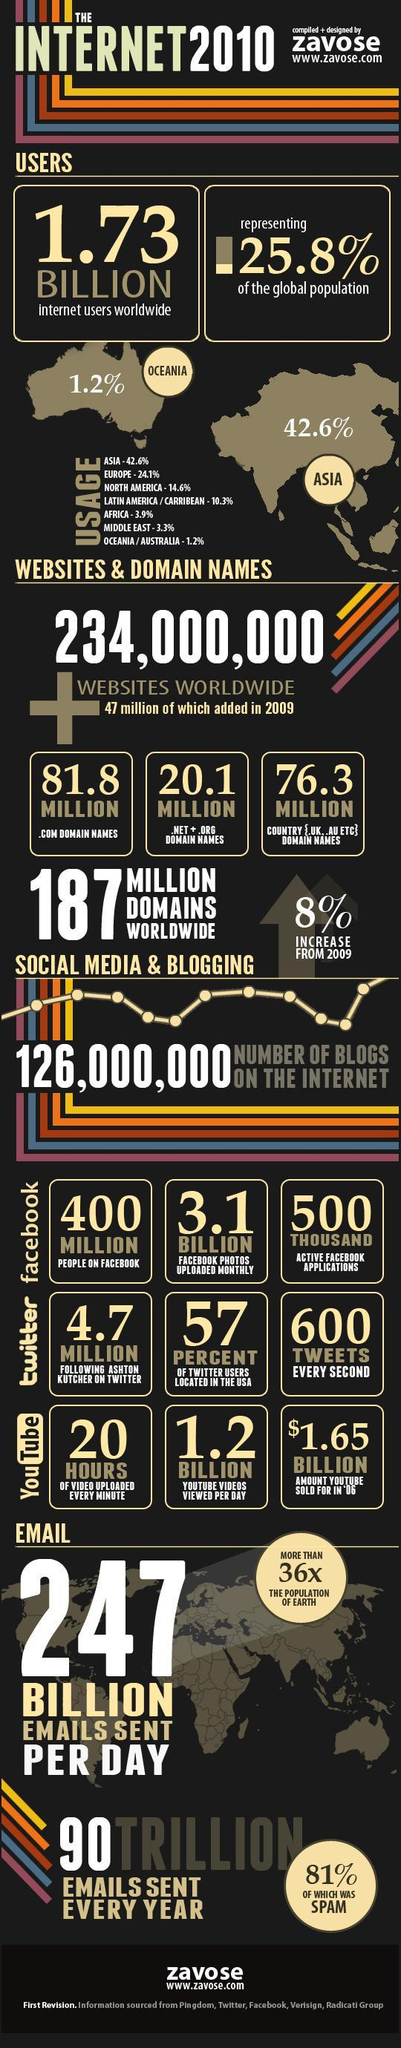What is total domain names added in 2009 in .com, .net+.org, and country categories?
Answer the question with a short phrase. 178.2 million What is percentage difference of internet users in Asia and Oceania ? 41.4% 